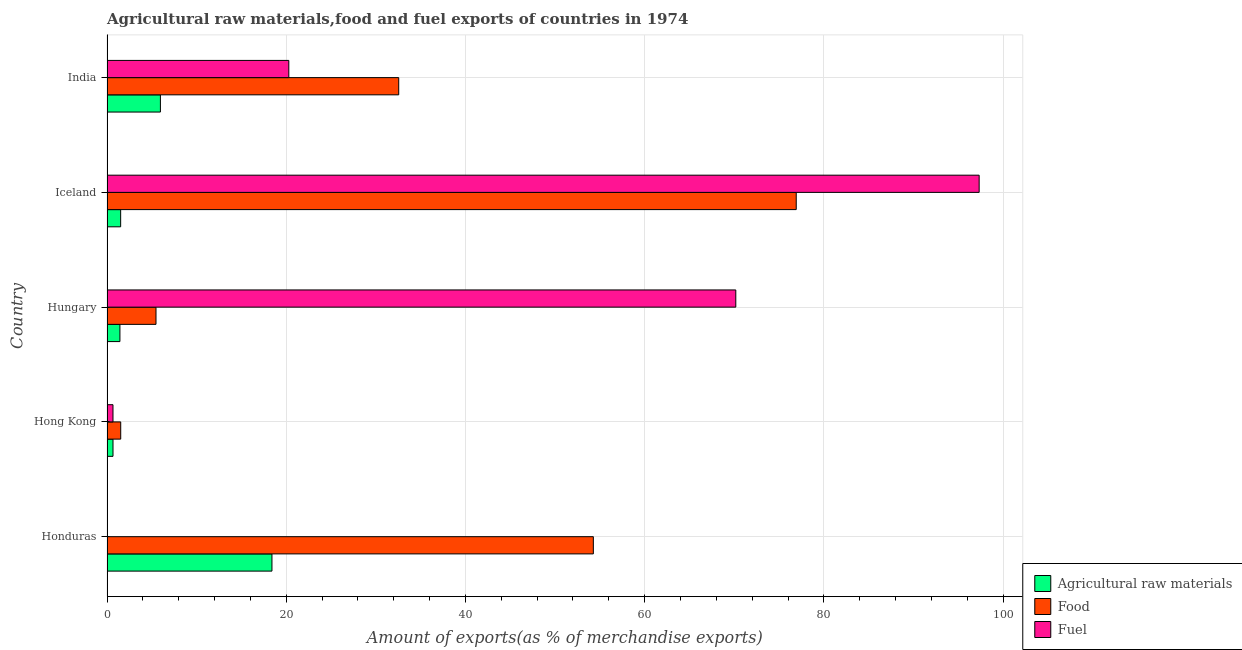How many different coloured bars are there?
Your response must be concise. 3. How many groups of bars are there?
Make the answer very short. 5. Are the number of bars on each tick of the Y-axis equal?
Make the answer very short. Yes. How many bars are there on the 3rd tick from the bottom?
Keep it short and to the point. 3. What is the label of the 4th group of bars from the top?
Give a very brief answer. Hong Kong. What is the percentage of raw materials exports in India?
Provide a short and direct response. 5.96. Across all countries, what is the maximum percentage of food exports?
Your response must be concise. 76.92. Across all countries, what is the minimum percentage of raw materials exports?
Provide a succinct answer. 0.67. In which country was the percentage of fuel exports minimum?
Provide a succinct answer. Honduras. What is the total percentage of fuel exports in the graph?
Your answer should be compact. 188.48. What is the difference between the percentage of fuel exports in Hungary and that in India?
Your answer should be compact. 49.88. What is the difference between the percentage of raw materials exports in Hungary and the percentage of fuel exports in India?
Your answer should be compact. -18.85. What is the difference between the percentage of raw materials exports and percentage of food exports in Hong Kong?
Offer a terse response. -0.86. In how many countries, is the percentage of raw materials exports greater than 28 %?
Offer a very short reply. 0. What is the ratio of the percentage of raw materials exports in Iceland to that in India?
Offer a very short reply. 0.26. What is the difference between the highest and the second highest percentage of raw materials exports?
Make the answer very short. 12.45. What is the difference between the highest and the lowest percentage of food exports?
Keep it short and to the point. 75.39. Is the sum of the percentage of fuel exports in Hungary and Iceland greater than the maximum percentage of raw materials exports across all countries?
Your answer should be compact. Yes. What does the 1st bar from the top in India represents?
Your answer should be very brief. Fuel. What does the 2nd bar from the bottom in Hong Kong represents?
Offer a terse response. Food. Are all the bars in the graph horizontal?
Give a very brief answer. Yes. How many countries are there in the graph?
Ensure brevity in your answer.  5. Are the values on the major ticks of X-axis written in scientific E-notation?
Your answer should be compact. No. Does the graph contain any zero values?
Make the answer very short. No. Where does the legend appear in the graph?
Ensure brevity in your answer.  Bottom right. How many legend labels are there?
Provide a short and direct response. 3. What is the title of the graph?
Keep it short and to the point. Agricultural raw materials,food and fuel exports of countries in 1974. Does "Agricultural raw materials" appear as one of the legend labels in the graph?
Ensure brevity in your answer.  Yes. What is the label or title of the X-axis?
Offer a terse response. Amount of exports(as % of merchandise exports). What is the Amount of exports(as % of merchandise exports) in Agricultural raw materials in Honduras?
Offer a terse response. 18.41. What is the Amount of exports(as % of merchandise exports) in Food in Honduras?
Offer a very short reply. 54.27. What is the Amount of exports(as % of merchandise exports) of Fuel in Honduras?
Keep it short and to the point. 0.02. What is the Amount of exports(as % of merchandise exports) in Agricultural raw materials in Hong Kong?
Give a very brief answer. 0.67. What is the Amount of exports(as % of merchandise exports) of Food in Hong Kong?
Provide a succinct answer. 1.53. What is the Amount of exports(as % of merchandise exports) of Fuel in Hong Kong?
Provide a succinct answer. 0.67. What is the Amount of exports(as % of merchandise exports) in Agricultural raw materials in Hungary?
Make the answer very short. 1.44. What is the Amount of exports(as % of merchandise exports) in Food in Hungary?
Your answer should be very brief. 5.47. What is the Amount of exports(as % of merchandise exports) in Fuel in Hungary?
Provide a succinct answer. 70.17. What is the Amount of exports(as % of merchandise exports) in Agricultural raw materials in Iceland?
Ensure brevity in your answer.  1.52. What is the Amount of exports(as % of merchandise exports) of Food in Iceland?
Your answer should be compact. 76.92. What is the Amount of exports(as % of merchandise exports) in Fuel in Iceland?
Make the answer very short. 97.33. What is the Amount of exports(as % of merchandise exports) of Agricultural raw materials in India?
Offer a very short reply. 5.96. What is the Amount of exports(as % of merchandise exports) of Food in India?
Your answer should be very brief. 32.56. What is the Amount of exports(as % of merchandise exports) of Fuel in India?
Provide a short and direct response. 20.29. Across all countries, what is the maximum Amount of exports(as % of merchandise exports) in Agricultural raw materials?
Ensure brevity in your answer.  18.41. Across all countries, what is the maximum Amount of exports(as % of merchandise exports) of Food?
Your response must be concise. 76.92. Across all countries, what is the maximum Amount of exports(as % of merchandise exports) of Fuel?
Offer a very short reply. 97.33. Across all countries, what is the minimum Amount of exports(as % of merchandise exports) of Agricultural raw materials?
Give a very brief answer. 0.67. Across all countries, what is the minimum Amount of exports(as % of merchandise exports) in Food?
Your answer should be very brief. 1.53. Across all countries, what is the minimum Amount of exports(as % of merchandise exports) of Fuel?
Offer a very short reply. 0.02. What is the total Amount of exports(as % of merchandise exports) of Agricultural raw materials in the graph?
Your answer should be very brief. 28. What is the total Amount of exports(as % of merchandise exports) in Food in the graph?
Provide a short and direct response. 170.75. What is the total Amount of exports(as % of merchandise exports) in Fuel in the graph?
Your response must be concise. 188.48. What is the difference between the Amount of exports(as % of merchandise exports) in Agricultural raw materials in Honduras and that in Hong Kong?
Provide a short and direct response. 17.74. What is the difference between the Amount of exports(as % of merchandise exports) of Food in Honduras and that in Hong Kong?
Provide a short and direct response. 52.74. What is the difference between the Amount of exports(as % of merchandise exports) of Fuel in Honduras and that in Hong Kong?
Your answer should be compact. -0.65. What is the difference between the Amount of exports(as % of merchandise exports) in Agricultural raw materials in Honduras and that in Hungary?
Make the answer very short. 16.97. What is the difference between the Amount of exports(as % of merchandise exports) of Food in Honduras and that in Hungary?
Make the answer very short. 48.81. What is the difference between the Amount of exports(as % of merchandise exports) in Fuel in Honduras and that in Hungary?
Offer a very short reply. -70.15. What is the difference between the Amount of exports(as % of merchandise exports) of Agricultural raw materials in Honduras and that in Iceland?
Make the answer very short. 16.88. What is the difference between the Amount of exports(as % of merchandise exports) of Food in Honduras and that in Iceland?
Provide a short and direct response. -22.64. What is the difference between the Amount of exports(as % of merchandise exports) of Fuel in Honduras and that in Iceland?
Offer a terse response. -97.31. What is the difference between the Amount of exports(as % of merchandise exports) in Agricultural raw materials in Honduras and that in India?
Your answer should be very brief. 12.45. What is the difference between the Amount of exports(as % of merchandise exports) in Food in Honduras and that in India?
Your response must be concise. 21.72. What is the difference between the Amount of exports(as % of merchandise exports) of Fuel in Honduras and that in India?
Offer a very short reply. -20.27. What is the difference between the Amount of exports(as % of merchandise exports) of Agricultural raw materials in Hong Kong and that in Hungary?
Keep it short and to the point. -0.77. What is the difference between the Amount of exports(as % of merchandise exports) of Food in Hong Kong and that in Hungary?
Ensure brevity in your answer.  -3.94. What is the difference between the Amount of exports(as % of merchandise exports) in Fuel in Hong Kong and that in Hungary?
Provide a succinct answer. -69.51. What is the difference between the Amount of exports(as % of merchandise exports) of Agricultural raw materials in Hong Kong and that in Iceland?
Your response must be concise. -0.86. What is the difference between the Amount of exports(as % of merchandise exports) in Food in Hong Kong and that in Iceland?
Ensure brevity in your answer.  -75.39. What is the difference between the Amount of exports(as % of merchandise exports) in Fuel in Hong Kong and that in Iceland?
Offer a terse response. -96.66. What is the difference between the Amount of exports(as % of merchandise exports) in Agricultural raw materials in Hong Kong and that in India?
Make the answer very short. -5.29. What is the difference between the Amount of exports(as % of merchandise exports) in Food in Hong Kong and that in India?
Provide a short and direct response. -31.03. What is the difference between the Amount of exports(as % of merchandise exports) of Fuel in Hong Kong and that in India?
Keep it short and to the point. -19.62. What is the difference between the Amount of exports(as % of merchandise exports) of Agricultural raw materials in Hungary and that in Iceland?
Your response must be concise. -0.08. What is the difference between the Amount of exports(as % of merchandise exports) in Food in Hungary and that in Iceland?
Offer a terse response. -71.45. What is the difference between the Amount of exports(as % of merchandise exports) of Fuel in Hungary and that in Iceland?
Your answer should be compact. -27.16. What is the difference between the Amount of exports(as % of merchandise exports) in Agricultural raw materials in Hungary and that in India?
Your response must be concise. -4.52. What is the difference between the Amount of exports(as % of merchandise exports) of Food in Hungary and that in India?
Provide a short and direct response. -27.09. What is the difference between the Amount of exports(as % of merchandise exports) of Fuel in Hungary and that in India?
Provide a short and direct response. 49.88. What is the difference between the Amount of exports(as % of merchandise exports) of Agricultural raw materials in Iceland and that in India?
Provide a short and direct response. -4.44. What is the difference between the Amount of exports(as % of merchandise exports) in Food in Iceland and that in India?
Your response must be concise. 44.36. What is the difference between the Amount of exports(as % of merchandise exports) in Fuel in Iceland and that in India?
Your answer should be very brief. 77.04. What is the difference between the Amount of exports(as % of merchandise exports) of Agricultural raw materials in Honduras and the Amount of exports(as % of merchandise exports) of Food in Hong Kong?
Keep it short and to the point. 16.88. What is the difference between the Amount of exports(as % of merchandise exports) in Agricultural raw materials in Honduras and the Amount of exports(as % of merchandise exports) in Fuel in Hong Kong?
Offer a very short reply. 17.74. What is the difference between the Amount of exports(as % of merchandise exports) in Food in Honduras and the Amount of exports(as % of merchandise exports) in Fuel in Hong Kong?
Your response must be concise. 53.61. What is the difference between the Amount of exports(as % of merchandise exports) of Agricultural raw materials in Honduras and the Amount of exports(as % of merchandise exports) of Food in Hungary?
Keep it short and to the point. 12.94. What is the difference between the Amount of exports(as % of merchandise exports) in Agricultural raw materials in Honduras and the Amount of exports(as % of merchandise exports) in Fuel in Hungary?
Your answer should be very brief. -51.77. What is the difference between the Amount of exports(as % of merchandise exports) in Food in Honduras and the Amount of exports(as % of merchandise exports) in Fuel in Hungary?
Your response must be concise. -15.9. What is the difference between the Amount of exports(as % of merchandise exports) of Agricultural raw materials in Honduras and the Amount of exports(as % of merchandise exports) of Food in Iceland?
Provide a succinct answer. -58.51. What is the difference between the Amount of exports(as % of merchandise exports) in Agricultural raw materials in Honduras and the Amount of exports(as % of merchandise exports) in Fuel in Iceland?
Your response must be concise. -78.92. What is the difference between the Amount of exports(as % of merchandise exports) in Food in Honduras and the Amount of exports(as % of merchandise exports) in Fuel in Iceland?
Offer a very short reply. -43.06. What is the difference between the Amount of exports(as % of merchandise exports) of Agricultural raw materials in Honduras and the Amount of exports(as % of merchandise exports) of Food in India?
Offer a terse response. -14.15. What is the difference between the Amount of exports(as % of merchandise exports) of Agricultural raw materials in Honduras and the Amount of exports(as % of merchandise exports) of Fuel in India?
Your response must be concise. -1.88. What is the difference between the Amount of exports(as % of merchandise exports) in Food in Honduras and the Amount of exports(as % of merchandise exports) in Fuel in India?
Offer a very short reply. 33.99. What is the difference between the Amount of exports(as % of merchandise exports) in Agricultural raw materials in Hong Kong and the Amount of exports(as % of merchandise exports) in Food in Hungary?
Your answer should be compact. -4.8. What is the difference between the Amount of exports(as % of merchandise exports) in Agricultural raw materials in Hong Kong and the Amount of exports(as % of merchandise exports) in Fuel in Hungary?
Make the answer very short. -69.51. What is the difference between the Amount of exports(as % of merchandise exports) of Food in Hong Kong and the Amount of exports(as % of merchandise exports) of Fuel in Hungary?
Make the answer very short. -68.64. What is the difference between the Amount of exports(as % of merchandise exports) of Agricultural raw materials in Hong Kong and the Amount of exports(as % of merchandise exports) of Food in Iceland?
Provide a succinct answer. -76.25. What is the difference between the Amount of exports(as % of merchandise exports) of Agricultural raw materials in Hong Kong and the Amount of exports(as % of merchandise exports) of Fuel in Iceland?
Make the answer very short. -96.66. What is the difference between the Amount of exports(as % of merchandise exports) of Food in Hong Kong and the Amount of exports(as % of merchandise exports) of Fuel in Iceland?
Ensure brevity in your answer.  -95.8. What is the difference between the Amount of exports(as % of merchandise exports) in Agricultural raw materials in Hong Kong and the Amount of exports(as % of merchandise exports) in Food in India?
Offer a terse response. -31.89. What is the difference between the Amount of exports(as % of merchandise exports) of Agricultural raw materials in Hong Kong and the Amount of exports(as % of merchandise exports) of Fuel in India?
Provide a succinct answer. -19.62. What is the difference between the Amount of exports(as % of merchandise exports) in Food in Hong Kong and the Amount of exports(as % of merchandise exports) in Fuel in India?
Make the answer very short. -18.76. What is the difference between the Amount of exports(as % of merchandise exports) in Agricultural raw materials in Hungary and the Amount of exports(as % of merchandise exports) in Food in Iceland?
Offer a terse response. -75.48. What is the difference between the Amount of exports(as % of merchandise exports) of Agricultural raw materials in Hungary and the Amount of exports(as % of merchandise exports) of Fuel in Iceland?
Offer a terse response. -95.89. What is the difference between the Amount of exports(as % of merchandise exports) in Food in Hungary and the Amount of exports(as % of merchandise exports) in Fuel in Iceland?
Offer a terse response. -91.86. What is the difference between the Amount of exports(as % of merchandise exports) in Agricultural raw materials in Hungary and the Amount of exports(as % of merchandise exports) in Food in India?
Offer a terse response. -31.11. What is the difference between the Amount of exports(as % of merchandise exports) in Agricultural raw materials in Hungary and the Amount of exports(as % of merchandise exports) in Fuel in India?
Provide a succinct answer. -18.85. What is the difference between the Amount of exports(as % of merchandise exports) of Food in Hungary and the Amount of exports(as % of merchandise exports) of Fuel in India?
Offer a very short reply. -14.82. What is the difference between the Amount of exports(as % of merchandise exports) of Agricultural raw materials in Iceland and the Amount of exports(as % of merchandise exports) of Food in India?
Give a very brief answer. -31.03. What is the difference between the Amount of exports(as % of merchandise exports) in Agricultural raw materials in Iceland and the Amount of exports(as % of merchandise exports) in Fuel in India?
Ensure brevity in your answer.  -18.77. What is the difference between the Amount of exports(as % of merchandise exports) of Food in Iceland and the Amount of exports(as % of merchandise exports) of Fuel in India?
Your response must be concise. 56.63. What is the average Amount of exports(as % of merchandise exports) in Agricultural raw materials per country?
Provide a short and direct response. 5.6. What is the average Amount of exports(as % of merchandise exports) in Food per country?
Provide a succinct answer. 34.15. What is the average Amount of exports(as % of merchandise exports) in Fuel per country?
Ensure brevity in your answer.  37.7. What is the difference between the Amount of exports(as % of merchandise exports) of Agricultural raw materials and Amount of exports(as % of merchandise exports) of Food in Honduras?
Your answer should be compact. -35.87. What is the difference between the Amount of exports(as % of merchandise exports) of Agricultural raw materials and Amount of exports(as % of merchandise exports) of Fuel in Honduras?
Your answer should be very brief. 18.39. What is the difference between the Amount of exports(as % of merchandise exports) in Food and Amount of exports(as % of merchandise exports) in Fuel in Honduras?
Your answer should be compact. 54.26. What is the difference between the Amount of exports(as % of merchandise exports) in Agricultural raw materials and Amount of exports(as % of merchandise exports) in Food in Hong Kong?
Your answer should be compact. -0.86. What is the difference between the Amount of exports(as % of merchandise exports) of Agricultural raw materials and Amount of exports(as % of merchandise exports) of Fuel in Hong Kong?
Ensure brevity in your answer.  0. What is the difference between the Amount of exports(as % of merchandise exports) of Food and Amount of exports(as % of merchandise exports) of Fuel in Hong Kong?
Offer a very short reply. 0.86. What is the difference between the Amount of exports(as % of merchandise exports) in Agricultural raw materials and Amount of exports(as % of merchandise exports) in Food in Hungary?
Make the answer very short. -4.03. What is the difference between the Amount of exports(as % of merchandise exports) of Agricultural raw materials and Amount of exports(as % of merchandise exports) of Fuel in Hungary?
Provide a short and direct response. -68.73. What is the difference between the Amount of exports(as % of merchandise exports) of Food and Amount of exports(as % of merchandise exports) of Fuel in Hungary?
Make the answer very short. -64.71. What is the difference between the Amount of exports(as % of merchandise exports) in Agricultural raw materials and Amount of exports(as % of merchandise exports) in Food in Iceland?
Offer a terse response. -75.39. What is the difference between the Amount of exports(as % of merchandise exports) of Agricultural raw materials and Amount of exports(as % of merchandise exports) of Fuel in Iceland?
Your answer should be compact. -95.81. What is the difference between the Amount of exports(as % of merchandise exports) of Food and Amount of exports(as % of merchandise exports) of Fuel in Iceland?
Ensure brevity in your answer.  -20.41. What is the difference between the Amount of exports(as % of merchandise exports) of Agricultural raw materials and Amount of exports(as % of merchandise exports) of Food in India?
Your answer should be very brief. -26.6. What is the difference between the Amount of exports(as % of merchandise exports) of Agricultural raw materials and Amount of exports(as % of merchandise exports) of Fuel in India?
Give a very brief answer. -14.33. What is the difference between the Amount of exports(as % of merchandise exports) in Food and Amount of exports(as % of merchandise exports) in Fuel in India?
Ensure brevity in your answer.  12.27. What is the ratio of the Amount of exports(as % of merchandise exports) of Agricultural raw materials in Honduras to that in Hong Kong?
Keep it short and to the point. 27.54. What is the ratio of the Amount of exports(as % of merchandise exports) of Food in Honduras to that in Hong Kong?
Your answer should be compact. 35.47. What is the ratio of the Amount of exports(as % of merchandise exports) of Fuel in Honduras to that in Hong Kong?
Keep it short and to the point. 0.03. What is the ratio of the Amount of exports(as % of merchandise exports) in Agricultural raw materials in Honduras to that in Hungary?
Your response must be concise. 12.77. What is the ratio of the Amount of exports(as % of merchandise exports) in Food in Honduras to that in Hungary?
Your answer should be very brief. 9.93. What is the ratio of the Amount of exports(as % of merchandise exports) in Fuel in Honduras to that in Hungary?
Your answer should be compact. 0. What is the ratio of the Amount of exports(as % of merchandise exports) of Agricultural raw materials in Honduras to that in Iceland?
Offer a very short reply. 12.08. What is the ratio of the Amount of exports(as % of merchandise exports) of Food in Honduras to that in Iceland?
Make the answer very short. 0.71. What is the ratio of the Amount of exports(as % of merchandise exports) in Agricultural raw materials in Honduras to that in India?
Your answer should be very brief. 3.09. What is the ratio of the Amount of exports(as % of merchandise exports) of Food in Honduras to that in India?
Make the answer very short. 1.67. What is the ratio of the Amount of exports(as % of merchandise exports) of Agricultural raw materials in Hong Kong to that in Hungary?
Keep it short and to the point. 0.46. What is the ratio of the Amount of exports(as % of merchandise exports) of Food in Hong Kong to that in Hungary?
Provide a succinct answer. 0.28. What is the ratio of the Amount of exports(as % of merchandise exports) in Fuel in Hong Kong to that in Hungary?
Provide a short and direct response. 0.01. What is the ratio of the Amount of exports(as % of merchandise exports) in Agricultural raw materials in Hong Kong to that in Iceland?
Your answer should be very brief. 0.44. What is the ratio of the Amount of exports(as % of merchandise exports) of Food in Hong Kong to that in Iceland?
Ensure brevity in your answer.  0.02. What is the ratio of the Amount of exports(as % of merchandise exports) of Fuel in Hong Kong to that in Iceland?
Provide a succinct answer. 0.01. What is the ratio of the Amount of exports(as % of merchandise exports) of Agricultural raw materials in Hong Kong to that in India?
Provide a short and direct response. 0.11. What is the ratio of the Amount of exports(as % of merchandise exports) of Food in Hong Kong to that in India?
Offer a very short reply. 0.05. What is the ratio of the Amount of exports(as % of merchandise exports) in Fuel in Hong Kong to that in India?
Your response must be concise. 0.03. What is the ratio of the Amount of exports(as % of merchandise exports) of Agricultural raw materials in Hungary to that in Iceland?
Offer a terse response. 0.95. What is the ratio of the Amount of exports(as % of merchandise exports) of Food in Hungary to that in Iceland?
Ensure brevity in your answer.  0.07. What is the ratio of the Amount of exports(as % of merchandise exports) of Fuel in Hungary to that in Iceland?
Provide a short and direct response. 0.72. What is the ratio of the Amount of exports(as % of merchandise exports) in Agricultural raw materials in Hungary to that in India?
Provide a succinct answer. 0.24. What is the ratio of the Amount of exports(as % of merchandise exports) in Food in Hungary to that in India?
Ensure brevity in your answer.  0.17. What is the ratio of the Amount of exports(as % of merchandise exports) of Fuel in Hungary to that in India?
Make the answer very short. 3.46. What is the ratio of the Amount of exports(as % of merchandise exports) in Agricultural raw materials in Iceland to that in India?
Ensure brevity in your answer.  0.26. What is the ratio of the Amount of exports(as % of merchandise exports) of Food in Iceland to that in India?
Offer a terse response. 2.36. What is the ratio of the Amount of exports(as % of merchandise exports) of Fuel in Iceland to that in India?
Keep it short and to the point. 4.8. What is the difference between the highest and the second highest Amount of exports(as % of merchandise exports) in Agricultural raw materials?
Offer a terse response. 12.45. What is the difference between the highest and the second highest Amount of exports(as % of merchandise exports) of Food?
Give a very brief answer. 22.64. What is the difference between the highest and the second highest Amount of exports(as % of merchandise exports) in Fuel?
Make the answer very short. 27.16. What is the difference between the highest and the lowest Amount of exports(as % of merchandise exports) of Agricultural raw materials?
Provide a short and direct response. 17.74. What is the difference between the highest and the lowest Amount of exports(as % of merchandise exports) in Food?
Your answer should be compact. 75.39. What is the difference between the highest and the lowest Amount of exports(as % of merchandise exports) of Fuel?
Give a very brief answer. 97.31. 